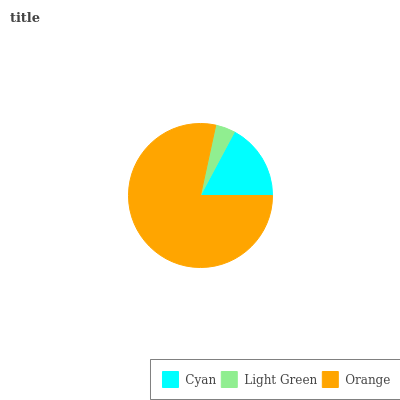Is Light Green the minimum?
Answer yes or no. Yes. Is Orange the maximum?
Answer yes or no. Yes. Is Orange the minimum?
Answer yes or no. No. Is Light Green the maximum?
Answer yes or no. No. Is Orange greater than Light Green?
Answer yes or no. Yes. Is Light Green less than Orange?
Answer yes or no. Yes. Is Light Green greater than Orange?
Answer yes or no. No. Is Orange less than Light Green?
Answer yes or no. No. Is Cyan the high median?
Answer yes or no. Yes. Is Cyan the low median?
Answer yes or no. Yes. Is Orange the high median?
Answer yes or no. No. Is Orange the low median?
Answer yes or no. No. 